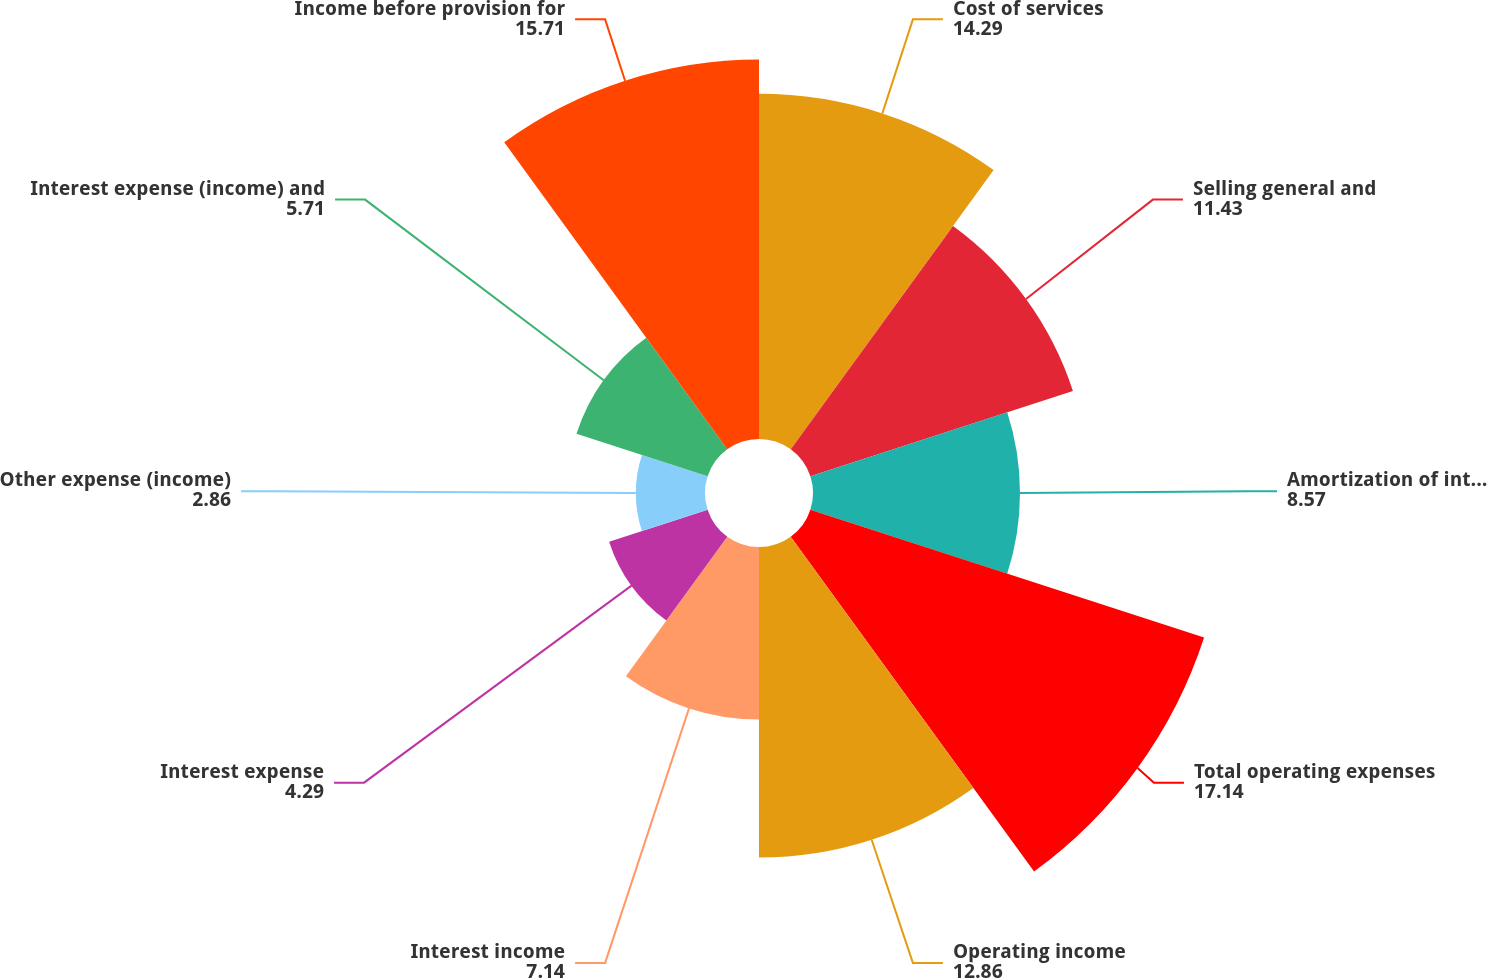Convert chart to OTSL. <chart><loc_0><loc_0><loc_500><loc_500><pie_chart><fcel>Cost of services<fcel>Selling general and<fcel>Amortization of intangible<fcel>Total operating expenses<fcel>Operating income<fcel>Interest income<fcel>Interest expense<fcel>Other expense (income)<fcel>Interest expense (income) and<fcel>Income before provision for<nl><fcel>14.29%<fcel>11.43%<fcel>8.57%<fcel>17.14%<fcel>12.86%<fcel>7.14%<fcel>4.29%<fcel>2.86%<fcel>5.71%<fcel>15.71%<nl></chart> 